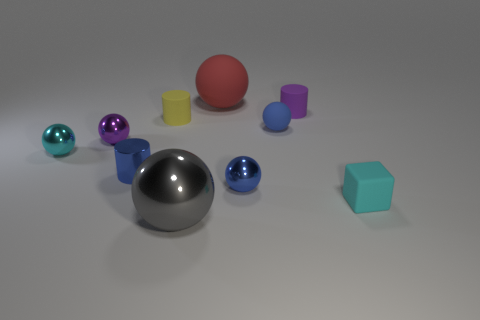What is the shape of the cyan shiny object?
Make the answer very short. Sphere. There is a tiny object behind the matte cylinder left of the big gray ball; what is its shape?
Make the answer very short. Cylinder. There is a tiny object that is the same color as the cube; what material is it?
Your response must be concise. Metal. What is the color of the other large thing that is the same material as the yellow thing?
Provide a short and direct response. Red. Is there any other thing that has the same size as the blue rubber thing?
Provide a short and direct response. Yes. There is a large ball that is on the right side of the big gray object; is its color the same as the tiny rubber object that is in front of the blue cylinder?
Provide a short and direct response. No. Is the number of tiny blue metal balls that are to the right of the purple rubber object greater than the number of balls in front of the large red matte ball?
Provide a short and direct response. No. What color is the other big thing that is the same shape as the gray shiny thing?
Give a very brief answer. Red. Is there anything else that is the same shape as the large gray metal object?
Offer a terse response. Yes. There is a tiny purple matte object; does it have the same shape as the small blue metallic thing that is on the left side of the tiny blue metallic sphere?
Make the answer very short. Yes. 